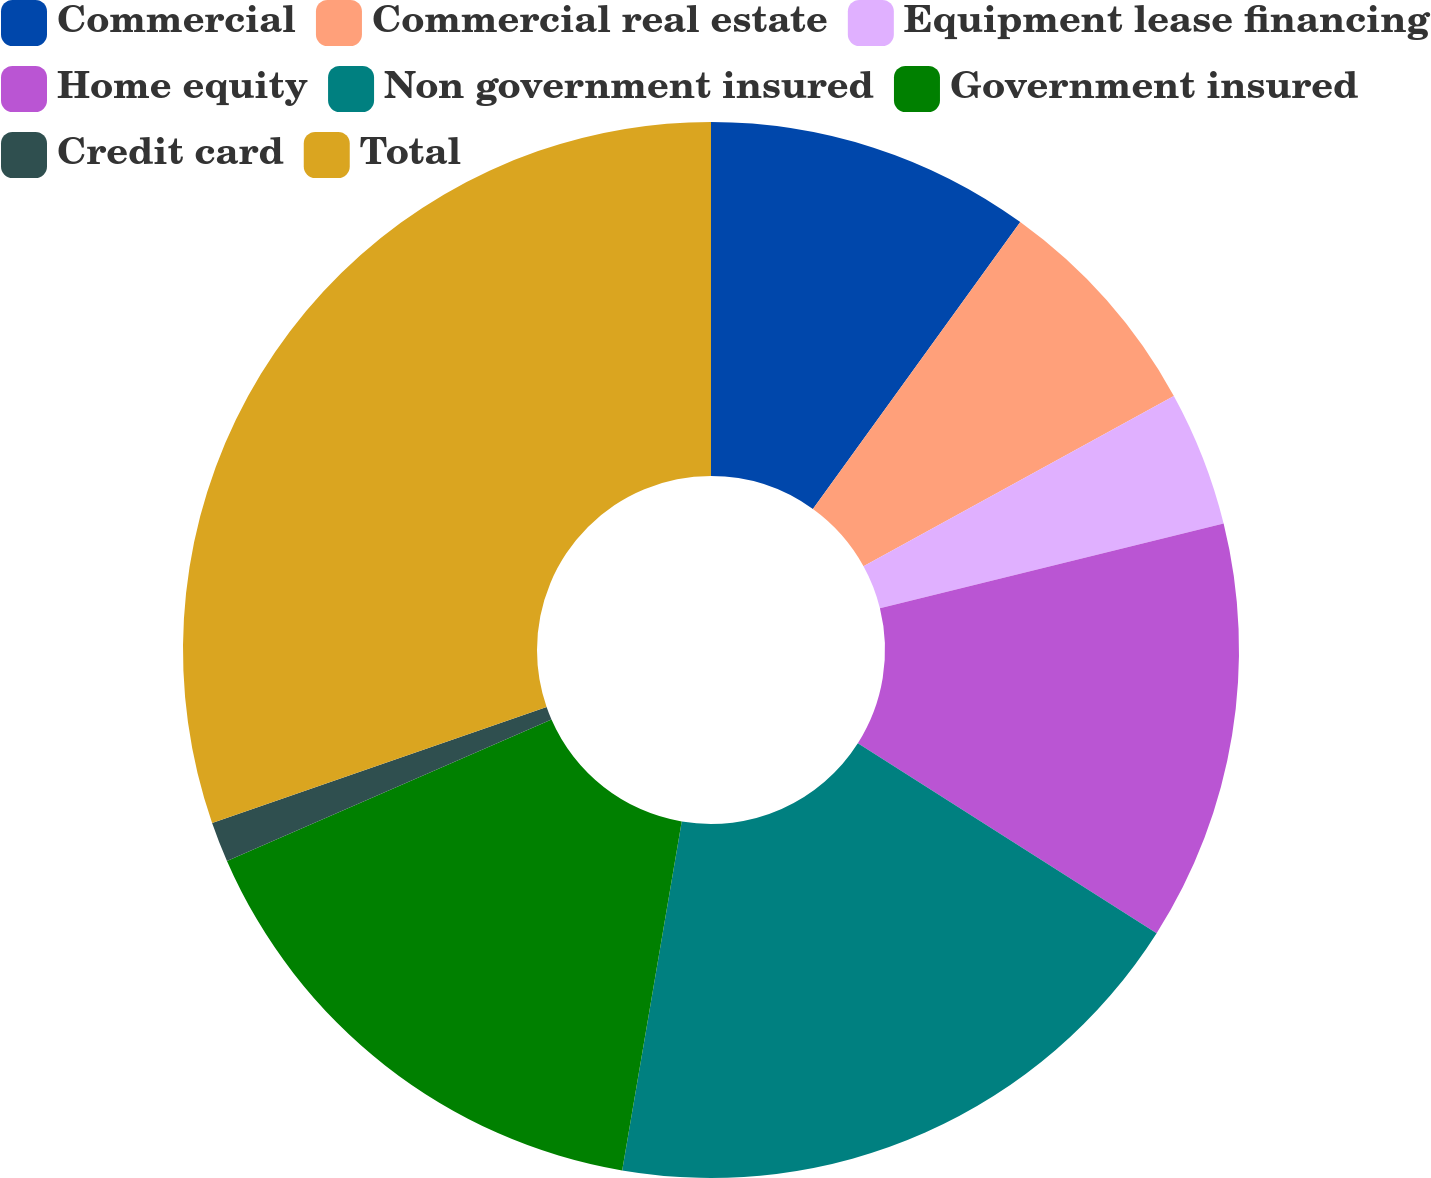Convert chart. <chart><loc_0><loc_0><loc_500><loc_500><pie_chart><fcel>Commercial<fcel>Commercial real estate<fcel>Equipment lease financing<fcel>Home equity<fcel>Non government insured<fcel>Government insured<fcel>Credit card<fcel>Total<nl><fcel>9.96%<fcel>7.05%<fcel>4.14%<fcel>12.86%<fcel>18.68%<fcel>15.77%<fcel>1.23%<fcel>30.31%<nl></chart> 